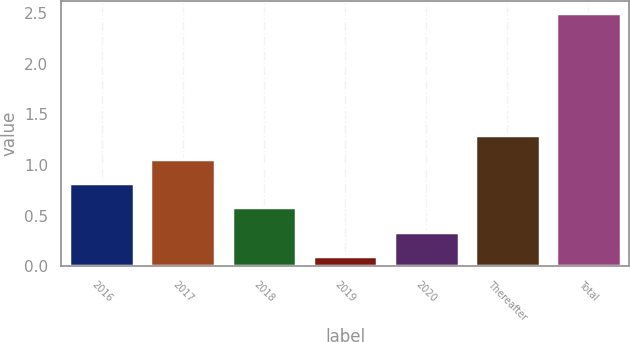Convert chart. <chart><loc_0><loc_0><loc_500><loc_500><bar_chart><fcel>2016<fcel>2017<fcel>2018<fcel>2019<fcel>2020<fcel>Thereafter<fcel>Total<nl><fcel>0.82<fcel>1.06<fcel>0.58<fcel>0.1<fcel>0.34<fcel>1.3<fcel>2.5<nl></chart> 